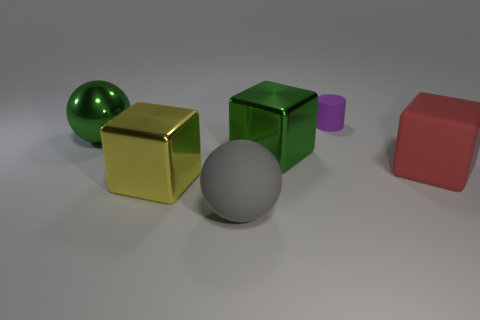How many large yellow shiny blocks are on the right side of the purple thing?
Make the answer very short. 0. How many balls are big brown things or metal things?
Your answer should be very brief. 1. What is the size of the object that is in front of the rubber block and behind the big gray ball?
Ensure brevity in your answer.  Large. How many other things are the same color as the rubber block?
Your answer should be compact. 0. Are the big gray thing and the big ball behind the yellow metallic block made of the same material?
Offer a very short reply. No. What number of things are either big things in front of the big shiny ball or large purple metallic objects?
Make the answer very short. 4. What shape is the matte object that is both on the right side of the large gray ball and in front of the purple thing?
Your answer should be compact. Cube. Is there any other thing that is the same size as the matte cylinder?
Keep it short and to the point. No. What size is the green object that is made of the same material as the big green block?
Make the answer very short. Large. How many objects are either cubes to the right of the purple object or large things that are to the left of the big gray sphere?
Your answer should be very brief. 3. 